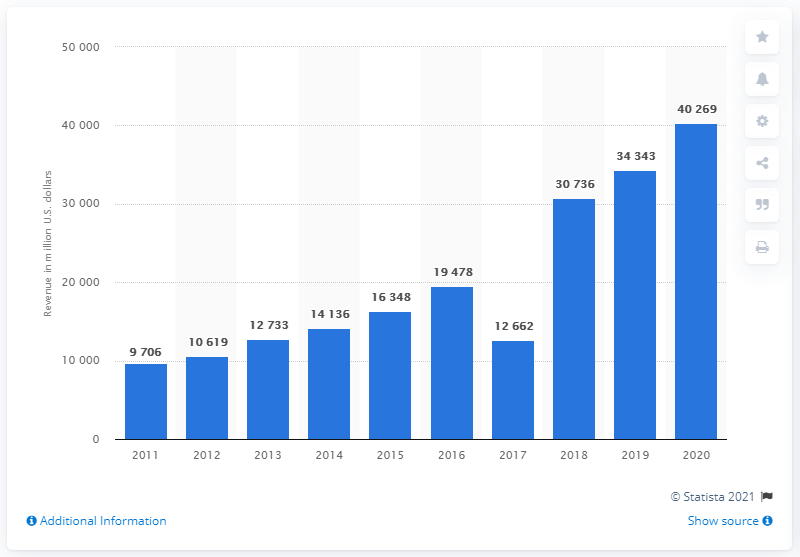Outline some significant characteristics in this image. In the previous year, Alphabet's net income was 343,434. Alphabet, the parent company of Google, reported a net income of $40,269 in its most recent fiscal year. 